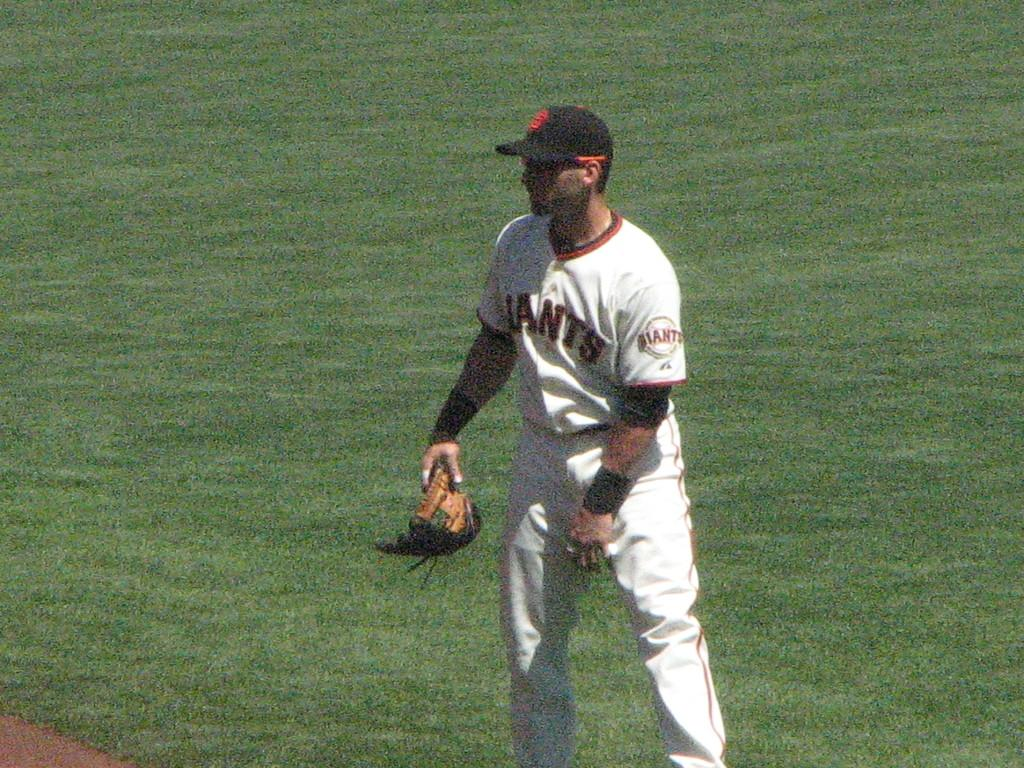<image>
Present a compact description of the photo's key features. A player in a Giants uniform isn't wearing his glove right now. 